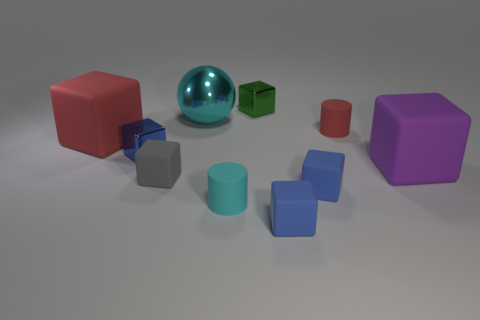Subtract all blue cubes. How many were subtracted if there are2blue cubes left? 1 Subtract all small blue cubes. How many cubes are left? 4 Subtract 1 cubes. How many cubes are left? 6 Subtract all gray rubber things. Subtract all tiny cyan cylinders. How many objects are left? 8 Add 5 big cyan spheres. How many big cyan spheres are left? 6 Add 3 tiny red rubber objects. How many tiny red rubber objects exist? 4 Subtract all purple cubes. How many cubes are left? 6 Subtract 1 green cubes. How many objects are left? 9 Subtract all cylinders. How many objects are left? 8 Subtract all brown blocks. Subtract all red cylinders. How many blocks are left? 7 